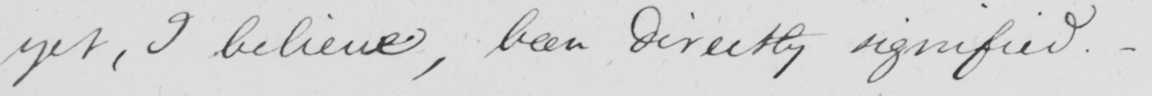What text is written in this handwritten line? yet , I believe , been directly signified . 